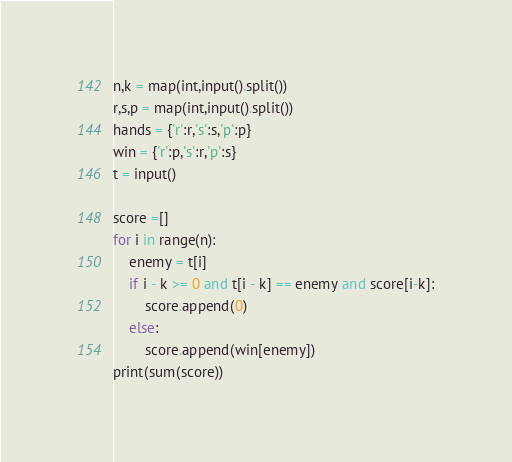<code> <loc_0><loc_0><loc_500><loc_500><_Python_>n,k = map(int,input().split())
r,s,p = map(int,input().split())
hands = {'r':r,'s':s,'p':p}
win = {'r':p,'s':r,'p':s}
t = input()

score =[]
for i in range(n):
    enemy = t[i]
    if i - k >= 0 and t[i - k] == enemy and score[i-k]:
        score.append(0)
    else:
        score.append(win[enemy])
print(sum(score))</code> 